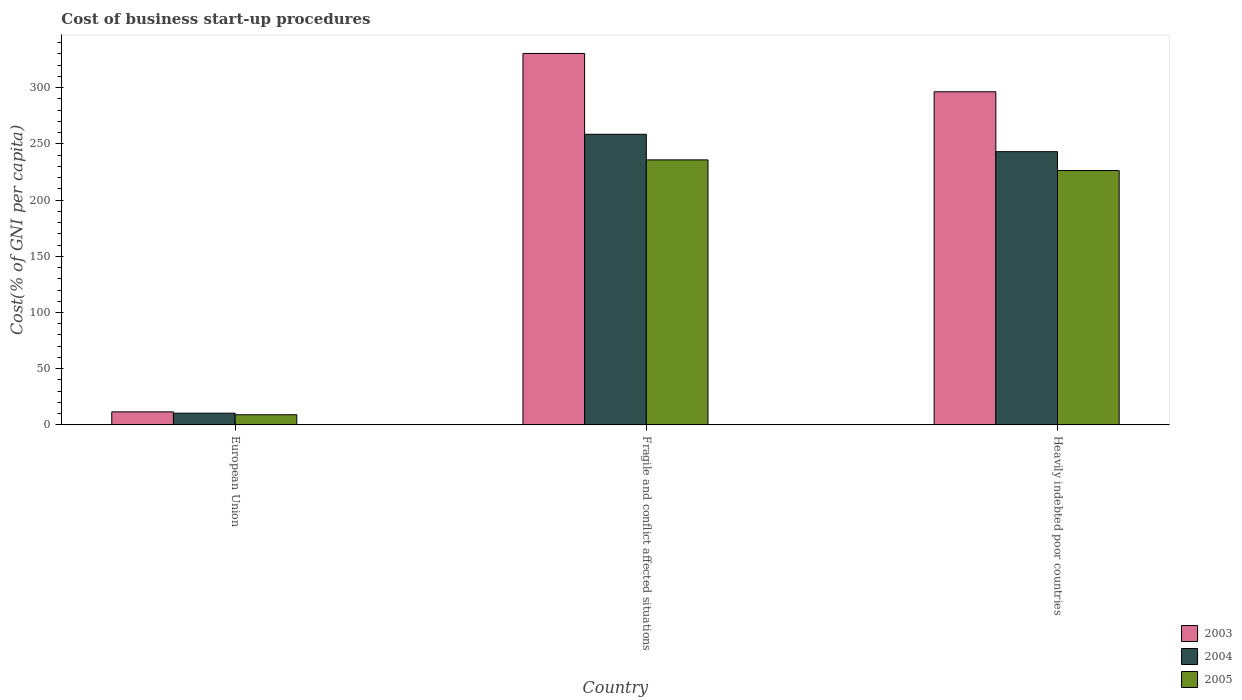How many different coloured bars are there?
Ensure brevity in your answer.  3. In how many cases, is the number of bars for a given country not equal to the number of legend labels?
Provide a short and direct response. 0. What is the cost of business start-up procedures in 2004 in European Union?
Ensure brevity in your answer.  10.42. Across all countries, what is the maximum cost of business start-up procedures in 2005?
Offer a very short reply. 235.78. Across all countries, what is the minimum cost of business start-up procedures in 2004?
Give a very brief answer. 10.42. In which country was the cost of business start-up procedures in 2004 maximum?
Give a very brief answer. Fragile and conflict affected situations. In which country was the cost of business start-up procedures in 2004 minimum?
Your answer should be very brief. European Union. What is the total cost of business start-up procedures in 2004 in the graph?
Provide a succinct answer. 512.06. What is the difference between the cost of business start-up procedures in 2005 in European Union and that in Heavily indebted poor countries?
Your response must be concise. -217.23. What is the difference between the cost of business start-up procedures in 2004 in Heavily indebted poor countries and the cost of business start-up procedures in 2003 in European Union?
Your answer should be compact. 231.48. What is the average cost of business start-up procedures in 2003 per country?
Your answer should be compact. 212.81. What is the difference between the cost of business start-up procedures of/in 2004 and cost of business start-up procedures of/in 2003 in European Union?
Provide a succinct answer. -1.18. What is the ratio of the cost of business start-up procedures in 2004 in European Union to that in Fragile and conflict affected situations?
Offer a terse response. 0.04. What is the difference between the highest and the second highest cost of business start-up procedures in 2005?
Ensure brevity in your answer.  -217.23. What is the difference between the highest and the lowest cost of business start-up procedures in 2004?
Make the answer very short. 248.12. How many countries are there in the graph?
Offer a terse response. 3. Does the graph contain any zero values?
Make the answer very short. No. Does the graph contain grids?
Keep it short and to the point. No. Where does the legend appear in the graph?
Offer a very short reply. Bottom right. How many legend labels are there?
Keep it short and to the point. 3. What is the title of the graph?
Your answer should be very brief. Cost of business start-up procedures. Does "1960" appear as one of the legend labels in the graph?
Your answer should be very brief. No. What is the label or title of the Y-axis?
Your answer should be very brief. Cost(% of GNI per capita). What is the Cost(% of GNI per capita) in 2003 in European Union?
Offer a terse response. 11.6. What is the Cost(% of GNI per capita) of 2004 in European Union?
Your answer should be compact. 10.42. What is the Cost(% of GNI per capita) of 2005 in European Union?
Keep it short and to the point. 9.05. What is the Cost(% of GNI per capita) of 2003 in Fragile and conflict affected situations?
Give a very brief answer. 330.46. What is the Cost(% of GNI per capita) in 2004 in Fragile and conflict affected situations?
Your answer should be very brief. 258.54. What is the Cost(% of GNI per capita) in 2005 in Fragile and conflict affected situations?
Give a very brief answer. 235.78. What is the Cost(% of GNI per capita) of 2003 in Heavily indebted poor countries?
Keep it short and to the point. 296.36. What is the Cost(% of GNI per capita) of 2004 in Heavily indebted poor countries?
Ensure brevity in your answer.  243.09. What is the Cost(% of GNI per capita) in 2005 in Heavily indebted poor countries?
Provide a succinct answer. 226.29. Across all countries, what is the maximum Cost(% of GNI per capita) of 2003?
Offer a terse response. 330.46. Across all countries, what is the maximum Cost(% of GNI per capita) in 2004?
Your answer should be compact. 258.54. Across all countries, what is the maximum Cost(% of GNI per capita) in 2005?
Your response must be concise. 235.78. Across all countries, what is the minimum Cost(% of GNI per capita) of 2003?
Your response must be concise. 11.6. Across all countries, what is the minimum Cost(% of GNI per capita) in 2004?
Your answer should be compact. 10.42. Across all countries, what is the minimum Cost(% of GNI per capita) of 2005?
Make the answer very short. 9.05. What is the total Cost(% of GNI per capita) of 2003 in the graph?
Provide a succinct answer. 638.43. What is the total Cost(% of GNI per capita) of 2004 in the graph?
Offer a very short reply. 512.06. What is the total Cost(% of GNI per capita) of 2005 in the graph?
Your response must be concise. 471.12. What is the difference between the Cost(% of GNI per capita) of 2003 in European Union and that in Fragile and conflict affected situations?
Your answer should be very brief. -318.86. What is the difference between the Cost(% of GNI per capita) of 2004 in European Union and that in Fragile and conflict affected situations?
Provide a succinct answer. -248.12. What is the difference between the Cost(% of GNI per capita) in 2005 in European Union and that in Fragile and conflict affected situations?
Ensure brevity in your answer.  -226.73. What is the difference between the Cost(% of GNI per capita) in 2003 in European Union and that in Heavily indebted poor countries?
Offer a very short reply. -284.76. What is the difference between the Cost(% of GNI per capita) in 2004 in European Union and that in Heavily indebted poor countries?
Your response must be concise. -232.66. What is the difference between the Cost(% of GNI per capita) of 2005 in European Union and that in Heavily indebted poor countries?
Your answer should be compact. -217.23. What is the difference between the Cost(% of GNI per capita) in 2003 in Fragile and conflict affected situations and that in Heavily indebted poor countries?
Your answer should be very brief. 34.1. What is the difference between the Cost(% of GNI per capita) of 2004 in Fragile and conflict affected situations and that in Heavily indebted poor countries?
Make the answer very short. 15.46. What is the difference between the Cost(% of GNI per capita) in 2005 in Fragile and conflict affected situations and that in Heavily indebted poor countries?
Offer a terse response. 9.5. What is the difference between the Cost(% of GNI per capita) in 2003 in European Union and the Cost(% of GNI per capita) in 2004 in Fragile and conflict affected situations?
Your answer should be compact. -246.94. What is the difference between the Cost(% of GNI per capita) of 2003 in European Union and the Cost(% of GNI per capita) of 2005 in Fragile and conflict affected situations?
Provide a succinct answer. -224.18. What is the difference between the Cost(% of GNI per capita) of 2004 in European Union and the Cost(% of GNI per capita) of 2005 in Fragile and conflict affected situations?
Your answer should be very brief. -225.36. What is the difference between the Cost(% of GNI per capita) of 2003 in European Union and the Cost(% of GNI per capita) of 2004 in Heavily indebted poor countries?
Give a very brief answer. -231.48. What is the difference between the Cost(% of GNI per capita) in 2003 in European Union and the Cost(% of GNI per capita) in 2005 in Heavily indebted poor countries?
Offer a terse response. -214.68. What is the difference between the Cost(% of GNI per capita) in 2004 in European Union and the Cost(% of GNI per capita) in 2005 in Heavily indebted poor countries?
Provide a succinct answer. -215.86. What is the difference between the Cost(% of GNI per capita) in 2003 in Fragile and conflict affected situations and the Cost(% of GNI per capita) in 2004 in Heavily indebted poor countries?
Keep it short and to the point. 87.37. What is the difference between the Cost(% of GNI per capita) in 2003 in Fragile and conflict affected situations and the Cost(% of GNI per capita) in 2005 in Heavily indebted poor countries?
Your answer should be very brief. 104.18. What is the difference between the Cost(% of GNI per capita) of 2004 in Fragile and conflict affected situations and the Cost(% of GNI per capita) of 2005 in Heavily indebted poor countries?
Offer a very short reply. 32.26. What is the average Cost(% of GNI per capita) of 2003 per country?
Offer a very short reply. 212.81. What is the average Cost(% of GNI per capita) of 2004 per country?
Provide a short and direct response. 170.69. What is the average Cost(% of GNI per capita) of 2005 per country?
Offer a terse response. 157.04. What is the difference between the Cost(% of GNI per capita) in 2003 and Cost(% of GNI per capita) in 2004 in European Union?
Ensure brevity in your answer.  1.18. What is the difference between the Cost(% of GNI per capita) of 2003 and Cost(% of GNI per capita) of 2005 in European Union?
Provide a succinct answer. 2.55. What is the difference between the Cost(% of GNI per capita) of 2004 and Cost(% of GNI per capita) of 2005 in European Union?
Your answer should be compact. 1.37. What is the difference between the Cost(% of GNI per capita) of 2003 and Cost(% of GNI per capita) of 2004 in Fragile and conflict affected situations?
Your response must be concise. 71.92. What is the difference between the Cost(% of GNI per capita) in 2003 and Cost(% of GNI per capita) in 2005 in Fragile and conflict affected situations?
Keep it short and to the point. 94.68. What is the difference between the Cost(% of GNI per capita) of 2004 and Cost(% of GNI per capita) of 2005 in Fragile and conflict affected situations?
Give a very brief answer. 22.76. What is the difference between the Cost(% of GNI per capita) in 2003 and Cost(% of GNI per capita) in 2004 in Heavily indebted poor countries?
Give a very brief answer. 53.27. What is the difference between the Cost(% of GNI per capita) in 2003 and Cost(% of GNI per capita) in 2005 in Heavily indebted poor countries?
Offer a terse response. 70.08. What is the difference between the Cost(% of GNI per capita) of 2004 and Cost(% of GNI per capita) of 2005 in Heavily indebted poor countries?
Your answer should be compact. 16.8. What is the ratio of the Cost(% of GNI per capita) in 2003 in European Union to that in Fragile and conflict affected situations?
Your response must be concise. 0.04. What is the ratio of the Cost(% of GNI per capita) in 2004 in European Union to that in Fragile and conflict affected situations?
Ensure brevity in your answer.  0.04. What is the ratio of the Cost(% of GNI per capita) of 2005 in European Union to that in Fragile and conflict affected situations?
Make the answer very short. 0.04. What is the ratio of the Cost(% of GNI per capita) of 2003 in European Union to that in Heavily indebted poor countries?
Keep it short and to the point. 0.04. What is the ratio of the Cost(% of GNI per capita) in 2004 in European Union to that in Heavily indebted poor countries?
Provide a short and direct response. 0.04. What is the ratio of the Cost(% of GNI per capita) of 2005 in European Union to that in Heavily indebted poor countries?
Your response must be concise. 0.04. What is the ratio of the Cost(% of GNI per capita) in 2003 in Fragile and conflict affected situations to that in Heavily indebted poor countries?
Provide a short and direct response. 1.12. What is the ratio of the Cost(% of GNI per capita) in 2004 in Fragile and conflict affected situations to that in Heavily indebted poor countries?
Your answer should be very brief. 1.06. What is the ratio of the Cost(% of GNI per capita) in 2005 in Fragile and conflict affected situations to that in Heavily indebted poor countries?
Your answer should be very brief. 1.04. What is the difference between the highest and the second highest Cost(% of GNI per capita) in 2003?
Your answer should be very brief. 34.1. What is the difference between the highest and the second highest Cost(% of GNI per capita) of 2004?
Your response must be concise. 15.46. What is the difference between the highest and the second highest Cost(% of GNI per capita) in 2005?
Offer a very short reply. 9.5. What is the difference between the highest and the lowest Cost(% of GNI per capita) of 2003?
Provide a succinct answer. 318.86. What is the difference between the highest and the lowest Cost(% of GNI per capita) of 2004?
Provide a succinct answer. 248.12. What is the difference between the highest and the lowest Cost(% of GNI per capita) in 2005?
Make the answer very short. 226.73. 